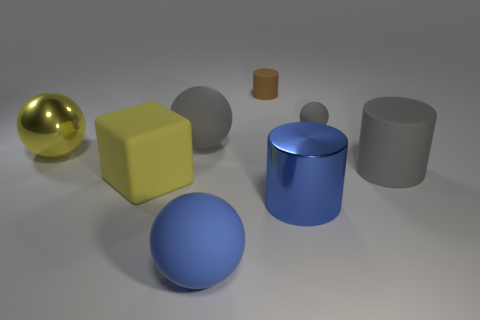Subtract all blue cylinders. How many cylinders are left? 2 Subtract all blue cylinders. How many cylinders are left? 2 Add 2 blue objects. How many objects exist? 10 Subtract 1 cylinders. How many cylinders are left? 2 Subtract all cubes. How many objects are left? 7 Add 3 large rubber spheres. How many large rubber spheres exist? 5 Subtract 0 green spheres. How many objects are left? 8 Subtract all blue cylinders. Subtract all red blocks. How many cylinders are left? 2 Subtract all yellow cubes. How many gray balls are left? 2 Subtract all blue spheres. Subtract all big cylinders. How many objects are left? 5 